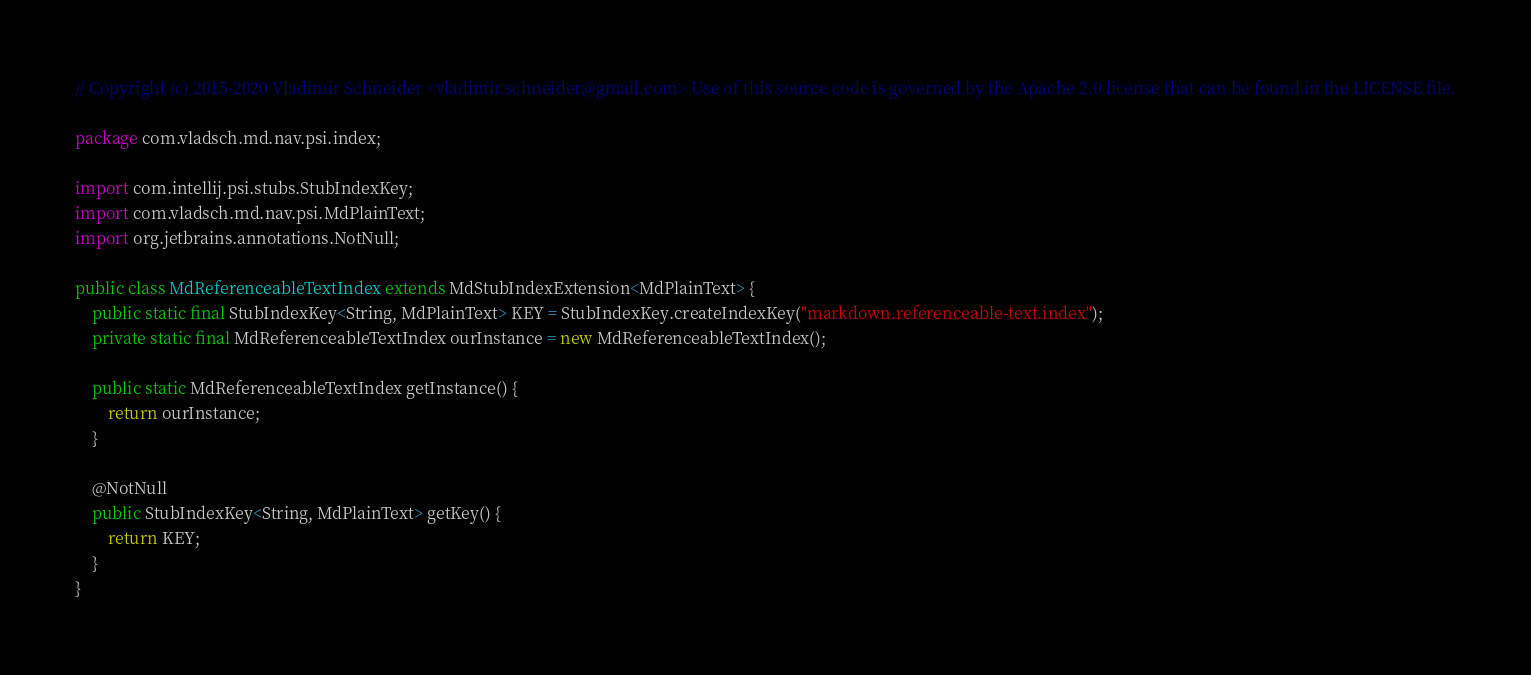<code> <loc_0><loc_0><loc_500><loc_500><_Java_>// Copyright (c) 2015-2020 Vladimir Schneider <vladimir.schneider@gmail.com> Use of this source code is governed by the Apache 2.0 license that can be found in the LICENSE file.

package com.vladsch.md.nav.psi.index;

import com.intellij.psi.stubs.StubIndexKey;
import com.vladsch.md.nav.psi.MdPlainText;
import org.jetbrains.annotations.NotNull;

public class MdReferenceableTextIndex extends MdStubIndexExtension<MdPlainText> {
    public static final StubIndexKey<String, MdPlainText> KEY = StubIndexKey.createIndexKey("markdown.referenceable-text.index");
    private static final MdReferenceableTextIndex ourInstance = new MdReferenceableTextIndex();

    public static MdReferenceableTextIndex getInstance() {
        return ourInstance;
    }

    @NotNull
    public StubIndexKey<String, MdPlainText> getKey() {
        return KEY;
    }
}
</code> 